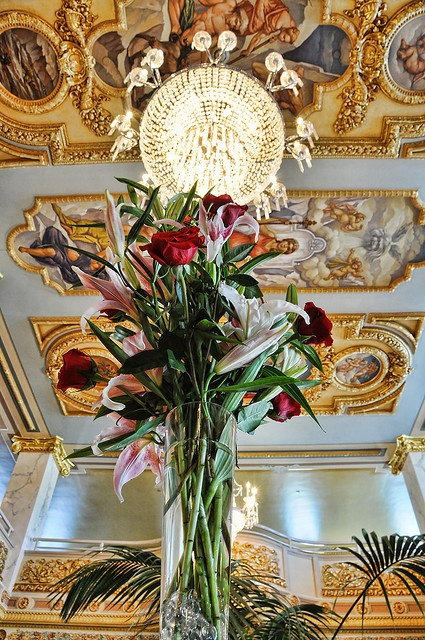Describe the objects in this image and their specific colors. I can see a vase in olive, black, darkgray, darkgreen, and gray tones in this image. 